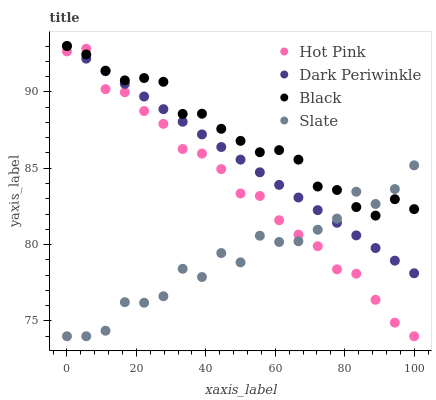Does Slate have the minimum area under the curve?
Answer yes or no. Yes. Does Black have the maximum area under the curve?
Answer yes or no. Yes. Does Hot Pink have the minimum area under the curve?
Answer yes or no. No. Does Hot Pink have the maximum area under the curve?
Answer yes or no. No. Is Dark Periwinkle the smoothest?
Answer yes or no. Yes. Is Slate the roughest?
Answer yes or no. Yes. Is Hot Pink the smoothest?
Answer yes or no. No. Is Hot Pink the roughest?
Answer yes or no. No. Does Slate have the lowest value?
Answer yes or no. Yes. Does Black have the lowest value?
Answer yes or no. No. Does Dark Periwinkle have the highest value?
Answer yes or no. Yes. Does Hot Pink have the highest value?
Answer yes or no. No. Does Slate intersect Hot Pink?
Answer yes or no. Yes. Is Slate less than Hot Pink?
Answer yes or no. No. Is Slate greater than Hot Pink?
Answer yes or no. No. 